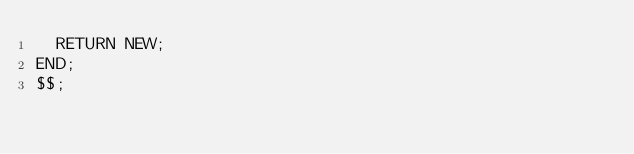<code> <loc_0><loc_0><loc_500><loc_500><_SQL_>  RETURN NEW;
END;
$$;
</code> 